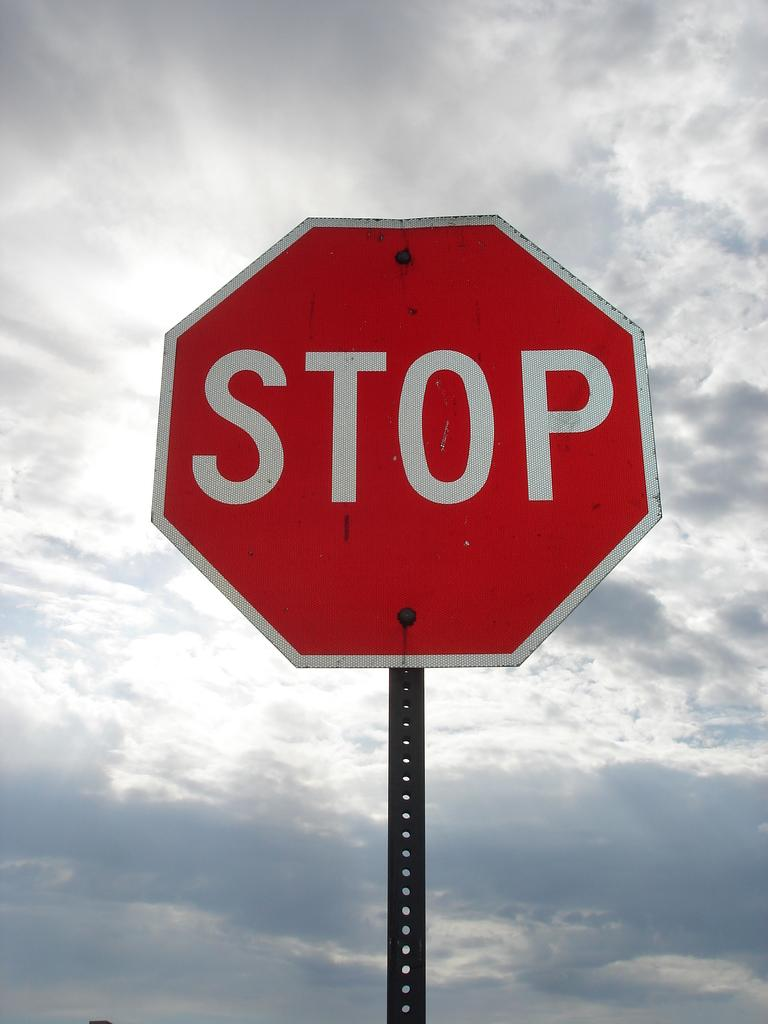<image>
Summarize the visual content of the image. a red and white stop sign with clouds behind it. 